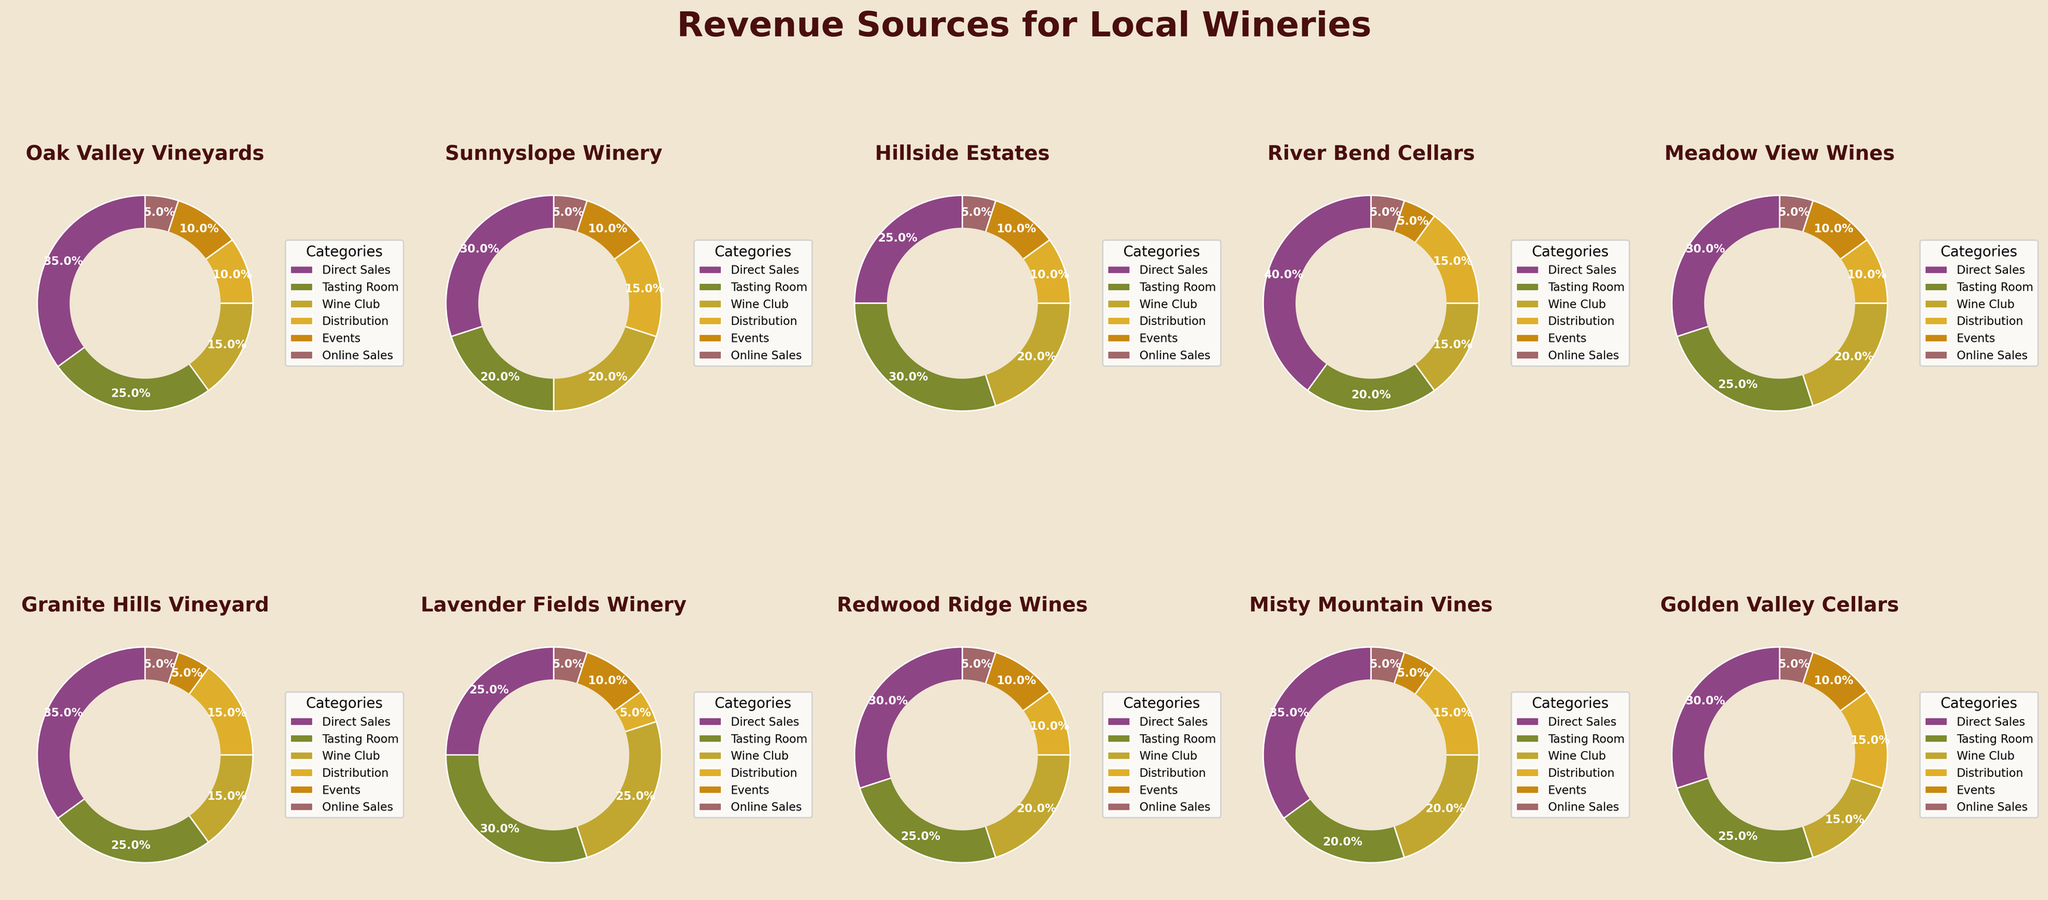Which winery has the highest percentage of revenue from Direct Sales? To find this, we look at the Direct Sales portion of each pie chart and identify the largest one. Oak Valley Vineyards and River Bend Cellars both have the highest Direct Sales at 40%. Therefore, we have to choose based on the highest value.
Answer: Oak Valley Vineyards and River Bend Cellars How does the revenue from Events for Lavender Fields Winery compare to Misty Mountain Vines? Check the segments marked for Events for both wineries. Lavender Fields Winery has 10% and Misty Mountain Vines has 5% under Events. Lavender Fields Winery has a higher percentage.
Answer: Lavender Fields Winery What is the average revenue percentage from Wine Club across all wineries? Sum the percentages of all wineries for Wine Club: 15+20+20+15+20+15+25+20+20+15. The total is 190. Divide by the number of wineries (10) to find the average: 190 / 10 = 19%.
Answer: 19% Which winery has the least revenue from Online Sales? Check each pie chart for the Online Sales segment. Note the smallest percentage, which appears as 5% for all wineries. They all have an identical revenue percentage from Online Sales.
Answer: All wineries Compare the revenue percentages from Distribution and Tasting Room for Granite Hills Vineyard. Which is higher? Checking the pie chart for Granite Hills Vineyard, Distribution is at 15% and Tasting Room is also at 15%. Both are equal.
Answer: Equal What is the total percentage of revenue from Tasting Room for Oak Valley Vineyards and Golden Valley Cellars combined? For Oak Valley Vineyards, Tasting Room is 25% and for Golden Valley Cellars, it is also 25%. Add these values: 25 + 25 = 50%.
Answer: 50% Which winery relies most on their Wine Club for revenue? Check the Wine Club segment of each winery. Lavender Fields Winery has the highest percentage with 25%.
Answer: Lavender Fields Winery What is the percentage difference in revenue from Direct Sales between Hillside Estates and River Bend Cellars? River Bend Cellars has 40% from Direct Sales, while Hillside Estates has 25%. Calculate the difference: 40 - 25 = 15%.
Answer: 15% Does any winery have equal revenue percentages from Direct Sales and Distribution? Check each pie chart for equal segments representing Direct Sales and Distribution. No winery shows equal percentages for both categories.
Answer: No Which two categories combined contribute the most to revenue for Sunnyslope Winery? Compare the segments for Sunnyslope Winery. The largest two are Direct Sales (30%) and Wine Club (20%). Add these together: 30 + 20 = 50%.
Answer: Direct Sales and Wine Club 